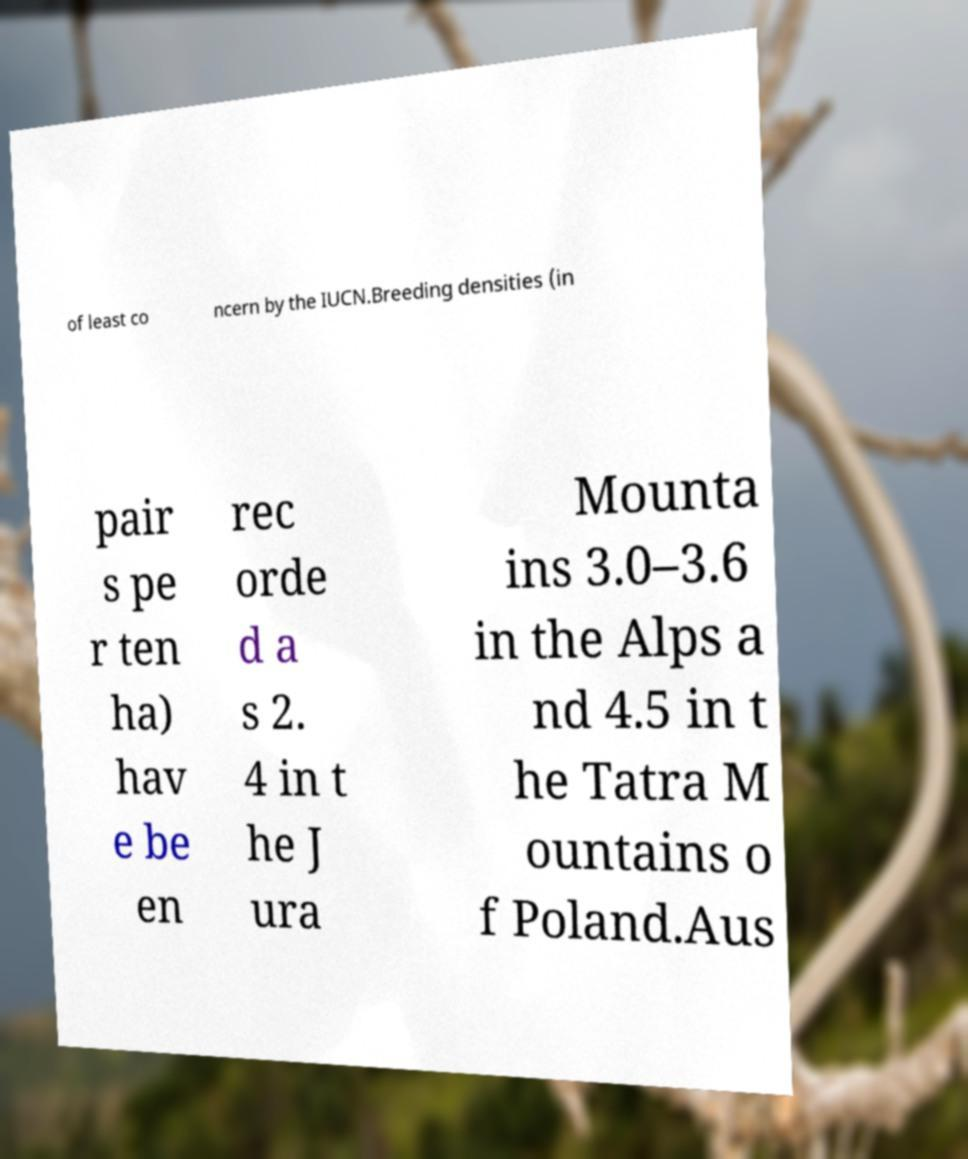Could you extract and type out the text from this image? of least co ncern by the IUCN.Breeding densities (in pair s pe r ten ha) hav e be en rec orde d a s 2. 4 in t he J ura Mounta ins 3.0–3.6 in the Alps a nd 4.5 in t he Tatra M ountains o f Poland.Aus 